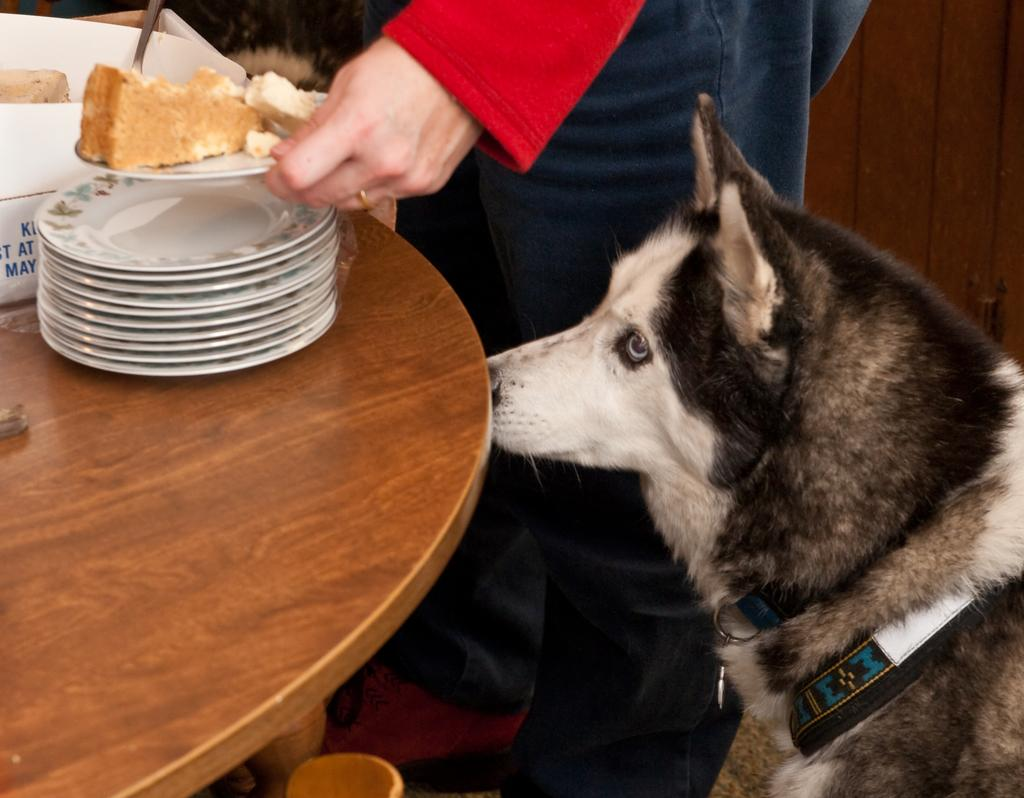What is present on the table in the image? There is food on a table in the image. What is used to serve the food on the table? There are plates on the table. Where is the dog located in the image? The dog is on the left side of the image. Who is holding food in a plate in the image? There is a person holding food in a plate. What type of rake is being used to prepare the food in the image? There is no rake present in the image; it is a scene involving food, plates, a dog, and a person holding food in a plate. How does the person in the image care for the dog on the left side? The image does not show any interaction between the person and the dog, so it is not possible to determine how the person cares for the dog. 